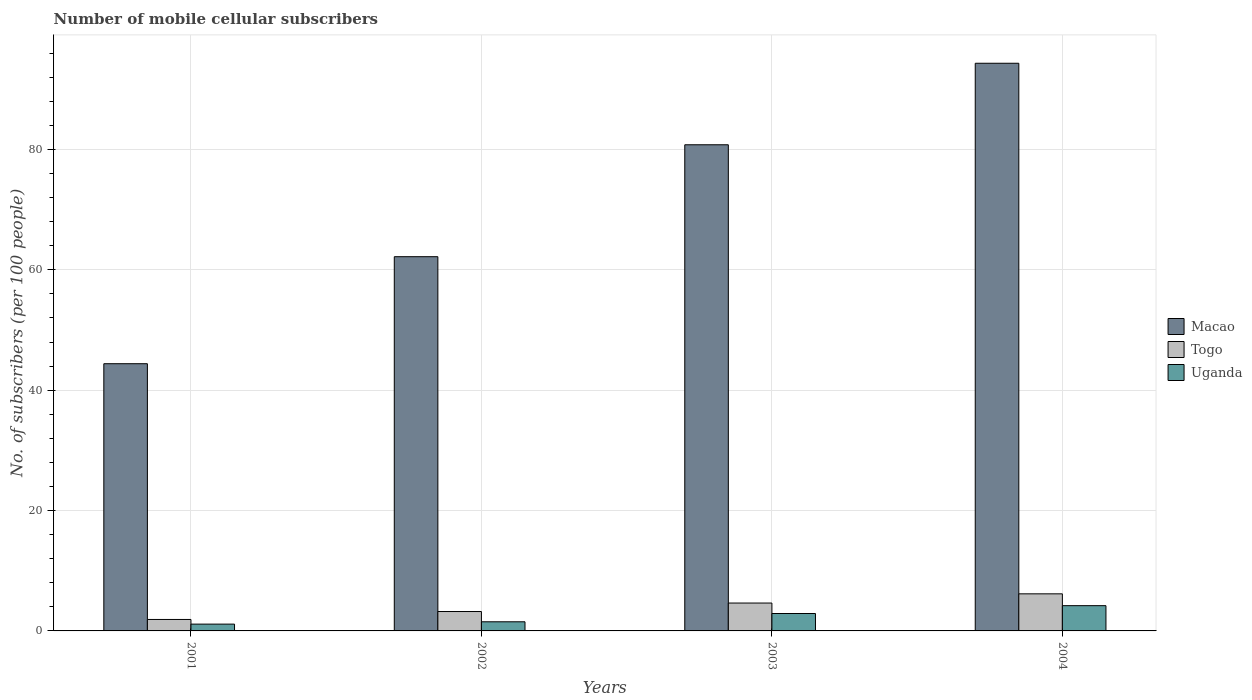How many different coloured bars are there?
Your answer should be very brief. 3. How many groups of bars are there?
Keep it short and to the point. 4. What is the label of the 4th group of bars from the left?
Offer a terse response. 2004. What is the number of mobile cellular subscribers in Uganda in 2003?
Offer a terse response. 2.89. Across all years, what is the maximum number of mobile cellular subscribers in Togo?
Make the answer very short. 6.16. Across all years, what is the minimum number of mobile cellular subscribers in Macao?
Provide a succinct answer. 44.39. In which year was the number of mobile cellular subscribers in Macao maximum?
Make the answer very short. 2004. In which year was the number of mobile cellular subscribers in Macao minimum?
Ensure brevity in your answer.  2001. What is the total number of mobile cellular subscribers in Togo in the graph?
Provide a succinct answer. 15.92. What is the difference between the number of mobile cellular subscribers in Uganda in 2002 and that in 2004?
Ensure brevity in your answer.  -2.68. What is the difference between the number of mobile cellular subscribers in Macao in 2002 and the number of mobile cellular subscribers in Uganda in 2004?
Ensure brevity in your answer.  57.98. What is the average number of mobile cellular subscribers in Togo per year?
Offer a terse response. 3.98. In the year 2001, what is the difference between the number of mobile cellular subscribers in Togo and number of mobile cellular subscribers in Macao?
Provide a short and direct response. -42.49. In how many years, is the number of mobile cellular subscribers in Macao greater than 48?
Your answer should be compact. 3. What is the ratio of the number of mobile cellular subscribers in Togo in 2002 to that in 2003?
Provide a succinct answer. 0.7. Is the difference between the number of mobile cellular subscribers in Togo in 2002 and 2004 greater than the difference between the number of mobile cellular subscribers in Macao in 2002 and 2004?
Your answer should be compact. Yes. What is the difference between the highest and the second highest number of mobile cellular subscribers in Macao?
Offer a terse response. 13.54. What is the difference between the highest and the lowest number of mobile cellular subscribers in Togo?
Provide a succinct answer. 4.26. What does the 2nd bar from the left in 2001 represents?
Provide a short and direct response. Togo. What does the 1st bar from the right in 2004 represents?
Keep it short and to the point. Uganda. Are all the bars in the graph horizontal?
Provide a short and direct response. No. Does the graph contain grids?
Provide a short and direct response. Yes. What is the title of the graph?
Your response must be concise. Number of mobile cellular subscribers. What is the label or title of the Y-axis?
Your response must be concise. No. of subscribers (per 100 people). What is the No. of subscribers (per 100 people) of Macao in 2001?
Offer a very short reply. 44.39. What is the No. of subscribers (per 100 people) in Togo in 2001?
Give a very brief answer. 1.9. What is the No. of subscribers (per 100 people) in Uganda in 2001?
Provide a short and direct response. 1.13. What is the No. of subscribers (per 100 people) of Macao in 2002?
Provide a short and direct response. 62.17. What is the No. of subscribers (per 100 people) in Togo in 2002?
Make the answer very short. 3.22. What is the No. of subscribers (per 100 people) of Uganda in 2002?
Give a very brief answer. 1.52. What is the No. of subscribers (per 100 people) of Macao in 2003?
Ensure brevity in your answer.  80.77. What is the No. of subscribers (per 100 people) of Togo in 2003?
Make the answer very short. 4.63. What is the No. of subscribers (per 100 people) in Uganda in 2003?
Provide a short and direct response. 2.89. What is the No. of subscribers (per 100 people) in Macao in 2004?
Offer a very short reply. 94.31. What is the No. of subscribers (per 100 people) of Togo in 2004?
Keep it short and to the point. 6.16. What is the No. of subscribers (per 100 people) in Uganda in 2004?
Your answer should be compact. 4.2. Across all years, what is the maximum No. of subscribers (per 100 people) in Macao?
Give a very brief answer. 94.31. Across all years, what is the maximum No. of subscribers (per 100 people) of Togo?
Your answer should be compact. 6.16. Across all years, what is the maximum No. of subscribers (per 100 people) of Uganda?
Your answer should be very brief. 4.2. Across all years, what is the minimum No. of subscribers (per 100 people) in Macao?
Provide a succinct answer. 44.39. Across all years, what is the minimum No. of subscribers (per 100 people) of Togo?
Give a very brief answer. 1.9. Across all years, what is the minimum No. of subscribers (per 100 people) in Uganda?
Offer a very short reply. 1.13. What is the total No. of subscribers (per 100 people) in Macao in the graph?
Offer a terse response. 281.64. What is the total No. of subscribers (per 100 people) of Togo in the graph?
Offer a terse response. 15.92. What is the total No. of subscribers (per 100 people) in Uganda in the graph?
Your answer should be very brief. 9.73. What is the difference between the No. of subscribers (per 100 people) of Macao in 2001 and that in 2002?
Your answer should be very brief. -17.78. What is the difference between the No. of subscribers (per 100 people) of Togo in 2001 and that in 2002?
Your answer should be compact. -1.32. What is the difference between the No. of subscribers (per 100 people) in Uganda in 2001 and that in 2002?
Give a very brief answer. -0.39. What is the difference between the No. of subscribers (per 100 people) of Macao in 2001 and that in 2003?
Offer a very short reply. -36.38. What is the difference between the No. of subscribers (per 100 people) of Togo in 2001 and that in 2003?
Offer a very short reply. -2.73. What is the difference between the No. of subscribers (per 100 people) in Uganda in 2001 and that in 2003?
Your answer should be compact. -1.76. What is the difference between the No. of subscribers (per 100 people) in Macao in 2001 and that in 2004?
Make the answer very short. -49.92. What is the difference between the No. of subscribers (per 100 people) of Togo in 2001 and that in 2004?
Offer a terse response. -4.26. What is the difference between the No. of subscribers (per 100 people) in Uganda in 2001 and that in 2004?
Give a very brief answer. -3.07. What is the difference between the No. of subscribers (per 100 people) in Macao in 2002 and that in 2003?
Provide a succinct answer. -18.6. What is the difference between the No. of subscribers (per 100 people) of Togo in 2002 and that in 2003?
Ensure brevity in your answer.  -1.41. What is the difference between the No. of subscribers (per 100 people) in Uganda in 2002 and that in 2003?
Your response must be concise. -1.38. What is the difference between the No. of subscribers (per 100 people) of Macao in 2002 and that in 2004?
Your answer should be very brief. -32.14. What is the difference between the No. of subscribers (per 100 people) of Togo in 2002 and that in 2004?
Keep it short and to the point. -2.94. What is the difference between the No. of subscribers (per 100 people) of Uganda in 2002 and that in 2004?
Your response must be concise. -2.68. What is the difference between the No. of subscribers (per 100 people) in Macao in 2003 and that in 2004?
Your answer should be compact. -13.54. What is the difference between the No. of subscribers (per 100 people) of Togo in 2003 and that in 2004?
Provide a succinct answer. -1.53. What is the difference between the No. of subscribers (per 100 people) in Uganda in 2003 and that in 2004?
Your answer should be compact. -1.3. What is the difference between the No. of subscribers (per 100 people) in Macao in 2001 and the No. of subscribers (per 100 people) in Togo in 2002?
Your answer should be compact. 41.17. What is the difference between the No. of subscribers (per 100 people) in Macao in 2001 and the No. of subscribers (per 100 people) in Uganda in 2002?
Ensure brevity in your answer.  42.88. What is the difference between the No. of subscribers (per 100 people) of Togo in 2001 and the No. of subscribers (per 100 people) of Uganda in 2002?
Offer a very short reply. 0.39. What is the difference between the No. of subscribers (per 100 people) in Macao in 2001 and the No. of subscribers (per 100 people) in Togo in 2003?
Provide a succinct answer. 39.76. What is the difference between the No. of subscribers (per 100 people) of Macao in 2001 and the No. of subscribers (per 100 people) of Uganda in 2003?
Your response must be concise. 41.5. What is the difference between the No. of subscribers (per 100 people) of Togo in 2001 and the No. of subscribers (per 100 people) of Uganda in 2003?
Your answer should be compact. -0.99. What is the difference between the No. of subscribers (per 100 people) in Macao in 2001 and the No. of subscribers (per 100 people) in Togo in 2004?
Give a very brief answer. 38.23. What is the difference between the No. of subscribers (per 100 people) of Macao in 2001 and the No. of subscribers (per 100 people) of Uganda in 2004?
Give a very brief answer. 40.2. What is the difference between the No. of subscribers (per 100 people) of Togo in 2001 and the No. of subscribers (per 100 people) of Uganda in 2004?
Offer a terse response. -2.29. What is the difference between the No. of subscribers (per 100 people) of Macao in 2002 and the No. of subscribers (per 100 people) of Togo in 2003?
Keep it short and to the point. 57.54. What is the difference between the No. of subscribers (per 100 people) of Macao in 2002 and the No. of subscribers (per 100 people) of Uganda in 2003?
Give a very brief answer. 59.28. What is the difference between the No. of subscribers (per 100 people) of Togo in 2002 and the No. of subscribers (per 100 people) of Uganda in 2003?
Your answer should be very brief. 0.33. What is the difference between the No. of subscribers (per 100 people) of Macao in 2002 and the No. of subscribers (per 100 people) of Togo in 2004?
Your answer should be compact. 56.01. What is the difference between the No. of subscribers (per 100 people) of Macao in 2002 and the No. of subscribers (per 100 people) of Uganda in 2004?
Offer a terse response. 57.98. What is the difference between the No. of subscribers (per 100 people) of Togo in 2002 and the No. of subscribers (per 100 people) of Uganda in 2004?
Offer a very short reply. -0.97. What is the difference between the No. of subscribers (per 100 people) in Macao in 2003 and the No. of subscribers (per 100 people) in Togo in 2004?
Ensure brevity in your answer.  74.61. What is the difference between the No. of subscribers (per 100 people) in Macao in 2003 and the No. of subscribers (per 100 people) in Uganda in 2004?
Offer a terse response. 76.57. What is the difference between the No. of subscribers (per 100 people) in Togo in 2003 and the No. of subscribers (per 100 people) in Uganda in 2004?
Offer a terse response. 0.44. What is the average No. of subscribers (per 100 people) in Macao per year?
Ensure brevity in your answer.  70.41. What is the average No. of subscribers (per 100 people) of Togo per year?
Offer a terse response. 3.98. What is the average No. of subscribers (per 100 people) in Uganda per year?
Give a very brief answer. 2.43. In the year 2001, what is the difference between the No. of subscribers (per 100 people) in Macao and No. of subscribers (per 100 people) in Togo?
Offer a very short reply. 42.49. In the year 2001, what is the difference between the No. of subscribers (per 100 people) in Macao and No. of subscribers (per 100 people) in Uganda?
Provide a succinct answer. 43.26. In the year 2001, what is the difference between the No. of subscribers (per 100 people) in Togo and No. of subscribers (per 100 people) in Uganda?
Your response must be concise. 0.77. In the year 2002, what is the difference between the No. of subscribers (per 100 people) of Macao and No. of subscribers (per 100 people) of Togo?
Your response must be concise. 58.95. In the year 2002, what is the difference between the No. of subscribers (per 100 people) in Macao and No. of subscribers (per 100 people) in Uganda?
Give a very brief answer. 60.66. In the year 2002, what is the difference between the No. of subscribers (per 100 people) of Togo and No. of subscribers (per 100 people) of Uganda?
Provide a short and direct response. 1.71. In the year 2003, what is the difference between the No. of subscribers (per 100 people) in Macao and No. of subscribers (per 100 people) in Togo?
Provide a short and direct response. 76.14. In the year 2003, what is the difference between the No. of subscribers (per 100 people) in Macao and No. of subscribers (per 100 people) in Uganda?
Make the answer very short. 77.88. In the year 2003, what is the difference between the No. of subscribers (per 100 people) in Togo and No. of subscribers (per 100 people) in Uganda?
Ensure brevity in your answer.  1.74. In the year 2004, what is the difference between the No. of subscribers (per 100 people) in Macao and No. of subscribers (per 100 people) in Togo?
Offer a very short reply. 88.15. In the year 2004, what is the difference between the No. of subscribers (per 100 people) in Macao and No. of subscribers (per 100 people) in Uganda?
Keep it short and to the point. 90.11. In the year 2004, what is the difference between the No. of subscribers (per 100 people) of Togo and No. of subscribers (per 100 people) of Uganda?
Offer a terse response. 1.97. What is the ratio of the No. of subscribers (per 100 people) of Macao in 2001 to that in 2002?
Your response must be concise. 0.71. What is the ratio of the No. of subscribers (per 100 people) of Togo in 2001 to that in 2002?
Your answer should be compact. 0.59. What is the ratio of the No. of subscribers (per 100 people) in Uganda in 2001 to that in 2002?
Your response must be concise. 0.75. What is the ratio of the No. of subscribers (per 100 people) of Macao in 2001 to that in 2003?
Your response must be concise. 0.55. What is the ratio of the No. of subscribers (per 100 people) of Togo in 2001 to that in 2003?
Keep it short and to the point. 0.41. What is the ratio of the No. of subscribers (per 100 people) in Uganda in 2001 to that in 2003?
Your response must be concise. 0.39. What is the ratio of the No. of subscribers (per 100 people) of Macao in 2001 to that in 2004?
Keep it short and to the point. 0.47. What is the ratio of the No. of subscribers (per 100 people) of Togo in 2001 to that in 2004?
Provide a succinct answer. 0.31. What is the ratio of the No. of subscribers (per 100 people) of Uganda in 2001 to that in 2004?
Your response must be concise. 0.27. What is the ratio of the No. of subscribers (per 100 people) in Macao in 2002 to that in 2003?
Give a very brief answer. 0.77. What is the ratio of the No. of subscribers (per 100 people) in Togo in 2002 to that in 2003?
Your answer should be very brief. 0.7. What is the ratio of the No. of subscribers (per 100 people) in Uganda in 2002 to that in 2003?
Keep it short and to the point. 0.52. What is the ratio of the No. of subscribers (per 100 people) in Macao in 2002 to that in 2004?
Your answer should be very brief. 0.66. What is the ratio of the No. of subscribers (per 100 people) of Togo in 2002 to that in 2004?
Your answer should be compact. 0.52. What is the ratio of the No. of subscribers (per 100 people) in Uganda in 2002 to that in 2004?
Give a very brief answer. 0.36. What is the ratio of the No. of subscribers (per 100 people) in Macao in 2003 to that in 2004?
Offer a very short reply. 0.86. What is the ratio of the No. of subscribers (per 100 people) in Togo in 2003 to that in 2004?
Your answer should be compact. 0.75. What is the ratio of the No. of subscribers (per 100 people) of Uganda in 2003 to that in 2004?
Your response must be concise. 0.69. What is the difference between the highest and the second highest No. of subscribers (per 100 people) in Macao?
Give a very brief answer. 13.54. What is the difference between the highest and the second highest No. of subscribers (per 100 people) of Togo?
Your answer should be compact. 1.53. What is the difference between the highest and the second highest No. of subscribers (per 100 people) in Uganda?
Your response must be concise. 1.3. What is the difference between the highest and the lowest No. of subscribers (per 100 people) of Macao?
Ensure brevity in your answer.  49.92. What is the difference between the highest and the lowest No. of subscribers (per 100 people) in Togo?
Your response must be concise. 4.26. What is the difference between the highest and the lowest No. of subscribers (per 100 people) in Uganda?
Your answer should be compact. 3.07. 